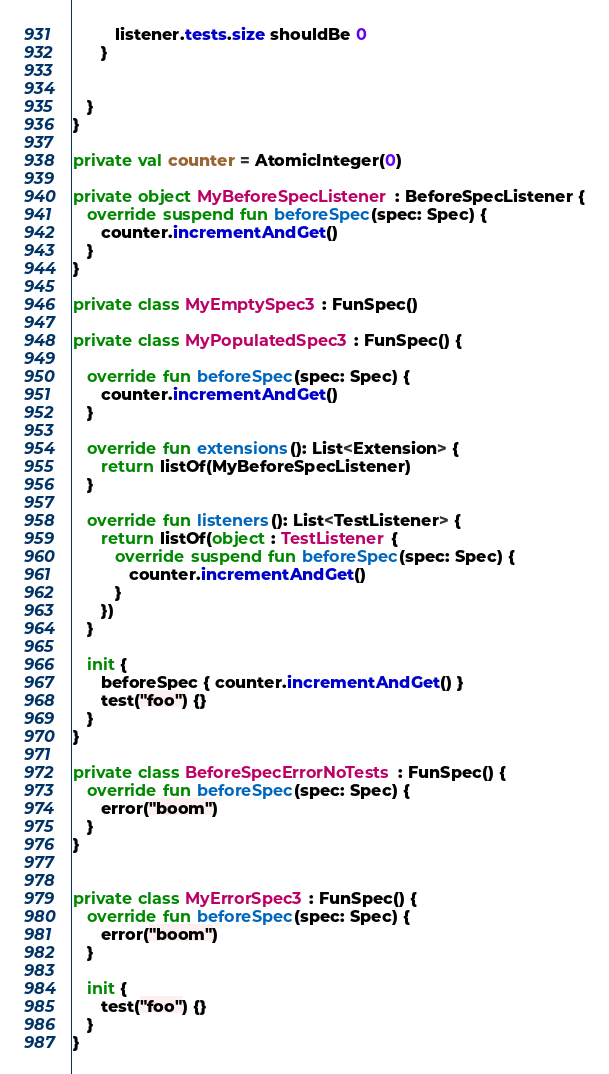Convert code to text. <code><loc_0><loc_0><loc_500><loc_500><_Kotlin_>         listener.tests.size shouldBe 0
      }


   }
}

private val counter = AtomicInteger(0)

private object MyBeforeSpecListener : BeforeSpecListener {
   override suspend fun beforeSpec(spec: Spec) {
      counter.incrementAndGet()
   }
}

private class MyEmptySpec3 : FunSpec()

private class MyPopulatedSpec3 : FunSpec() {

   override fun beforeSpec(spec: Spec) {
      counter.incrementAndGet()
   }

   override fun extensions(): List<Extension> {
      return listOf(MyBeforeSpecListener)
   }

   override fun listeners(): List<TestListener> {
      return listOf(object : TestListener {
         override suspend fun beforeSpec(spec: Spec) {
            counter.incrementAndGet()
         }
      })
   }

   init {
      beforeSpec { counter.incrementAndGet() }
      test("foo") {}
   }
}

private class BeforeSpecErrorNoTests : FunSpec() {
   override fun beforeSpec(spec: Spec) {
      error("boom")
   }
}


private class MyErrorSpec3 : FunSpec() {
   override fun beforeSpec(spec: Spec) {
      error("boom")
   }

   init {
      test("foo") {}
   }
}
</code> 